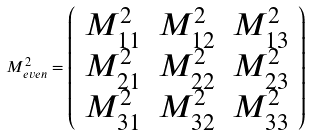<formula> <loc_0><loc_0><loc_500><loc_500>M _ { e v e n } ^ { 2 } = \left ( \begin{array} { c c c } M _ { 1 1 } ^ { 2 } & M _ { 1 2 } ^ { 2 } & M _ { 1 3 } ^ { 2 } \\ M _ { 2 1 } ^ { 2 } & M _ { 2 2 } ^ { 2 } & M _ { 2 3 } ^ { 2 } \\ M _ { 3 1 } ^ { 2 } & M _ { 3 2 } ^ { 2 } & M _ { 3 3 } ^ { 2 } \end{array} \right )</formula> 